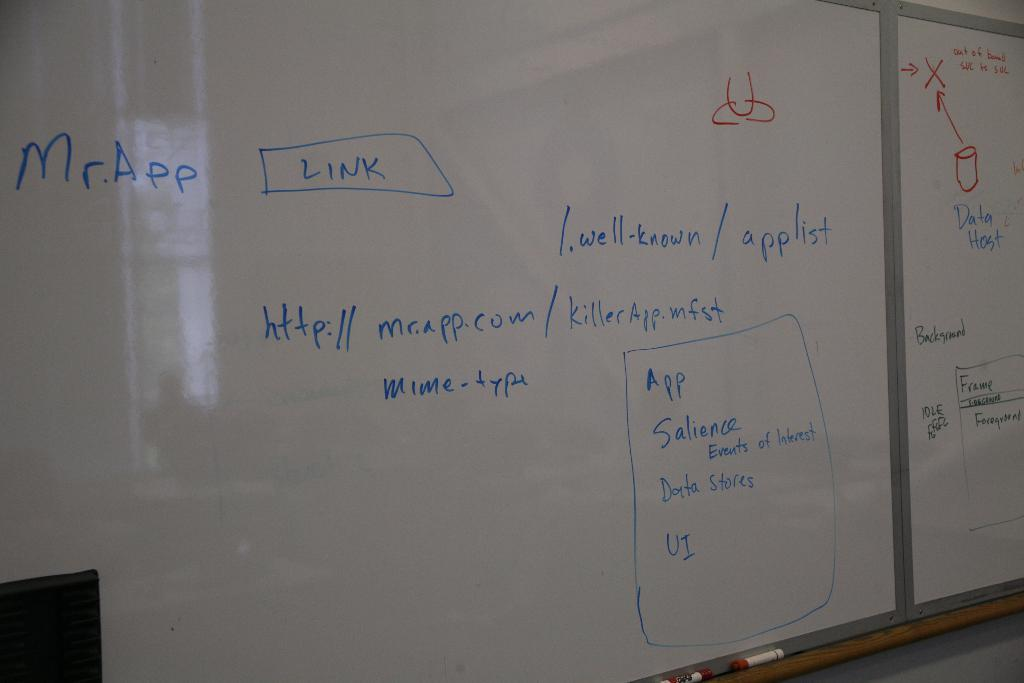<image>
Describe the image concisely. A whiteboard with the word Link written on it. 